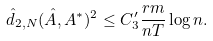<formula> <loc_0><loc_0><loc_500><loc_500>\hat { d } _ { 2 , N } ( \hat { A } , A ^ { * } ) ^ { 2 } \leq C _ { 3 } ^ { \prime } \frac { r m } { n T } \log n .</formula> 